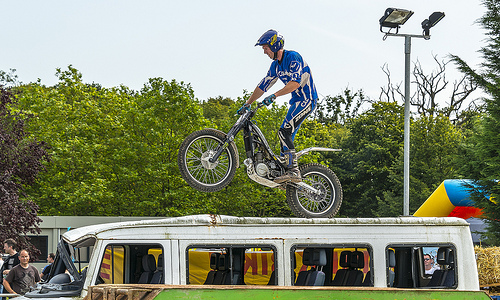<image>
Is there a tree behind the bike? Yes. From this viewpoint, the tree is positioned behind the bike, with the bike partially or fully occluding the tree. Where is the vehicle in relation to the man? Is it next to the man? No. The vehicle is not positioned next to the man. They are located in different areas of the scene. 